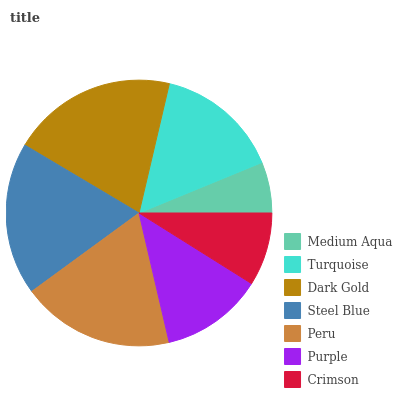Is Medium Aqua the minimum?
Answer yes or no. Yes. Is Dark Gold the maximum?
Answer yes or no. Yes. Is Turquoise the minimum?
Answer yes or no. No. Is Turquoise the maximum?
Answer yes or no. No. Is Turquoise greater than Medium Aqua?
Answer yes or no. Yes. Is Medium Aqua less than Turquoise?
Answer yes or no. Yes. Is Medium Aqua greater than Turquoise?
Answer yes or no. No. Is Turquoise less than Medium Aqua?
Answer yes or no. No. Is Turquoise the high median?
Answer yes or no. Yes. Is Turquoise the low median?
Answer yes or no. Yes. Is Dark Gold the high median?
Answer yes or no. No. Is Medium Aqua the low median?
Answer yes or no. No. 